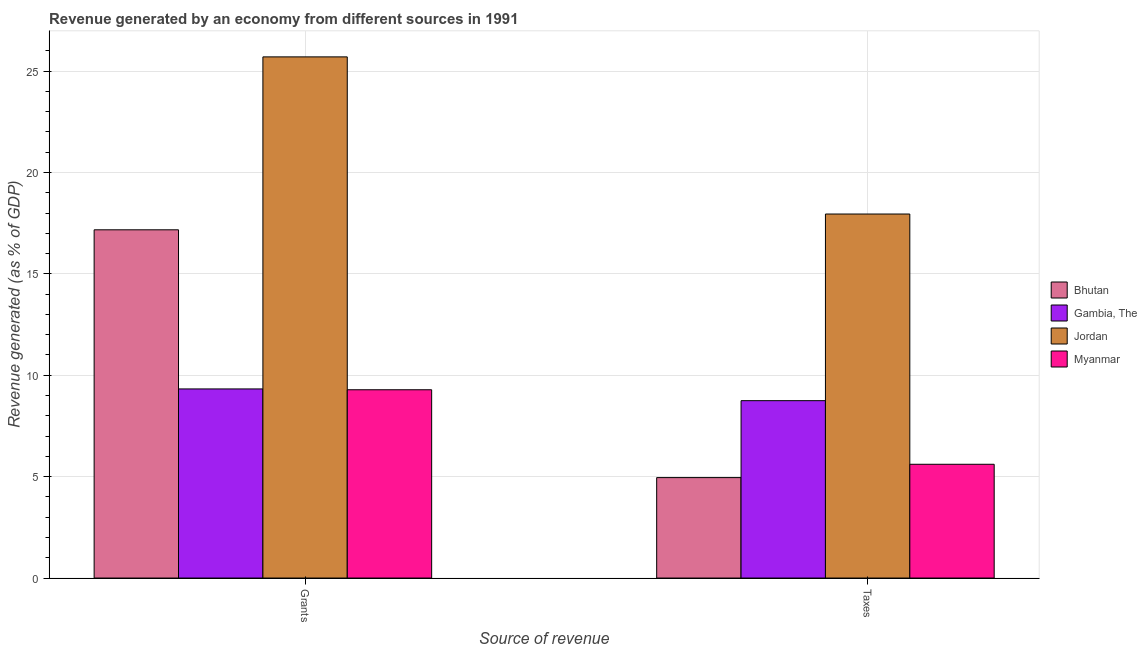How many different coloured bars are there?
Provide a succinct answer. 4. How many groups of bars are there?
Give a very brief answer. 2. How many bars are there on the 1st tick from the left?
Ensure brevity in your answer.  4. What is the label of the 1st group of bars from the left?
Provide a succinct answer. Grants. What is the revenue generated by taxes in Jordan?
Give a very brief answer. 17.95. Across all countries, what is the maximum revenue generated by taxes?
Offer a very short reply. 17.95. Across all countries, what is the minimum revenue generated by taxes?
Provide a short and direct response. 4.95. In which country was the revenue generated by taxes maximum?
Your answer should be compact. Jordan. In which country was the revenue generated by grants minimum?
Give a very brief answer. Myanmar. What is the total revenue generated by taxes in the graph?
Provide a succinct answer. 37.26. What is the difference between the revenue generated by taxes in Bhutan and that in Myanmar?
Your response must be concise. -0.66. What is the difference between the revenue generated by grants in Bhutan and the revenue generated by taxes in Jordan?
Your response must be concise. -0.78. What is the average revenue generated by taxes per country?
Offer a very short reply. 9.31. What is the difference between the revenue generated by grants and revenue generated by taxes in Myanmar?
Make the answer very short. 3.67. What is the ratio of the revenue generated by grants in Jordan to that in Bhutan?
Offer a very short reply. 1.5. Is the revenue generated by taxes in Myanmar less than that in Bhutan?
Your answer should be compact. No. In how many countries, is the revenue generated by grants greater than the average revenue generated by grants taken over all countries?
Keep it short and to the point. 2. What does the 1st bar from the left in Taxes represents?
Offer a very short reply. Bhutan. What does the 4th bar from the right in Grants represents?
Give a very brief answer. Bhutan. How many bars are there?
Provide a short and direct response. 8. Are all the bars in the graph horizontal?
Offer a terse response. No. How many countries are there in the graph?
Keep it short and to the point. 4. Where does the legend appear in the graph?
Ensure brevity in your answer.  Center right. How are the legend labels stacked?
Offer a terse response. Vertical. What is the title of the graph?
Give a very brief answer. Revenue generated by an economy from different sources in 1991. What is the label or title of the X-axis?
Ensure brevity in your answer.  Source of revenue. What is the label or title of the Y-axis?
Ensure brevity in your answer.  Revenue generated (as % of GDP). What is the Revenue generated (as % of GDP) in Bhutan in Grants?
Give a very brief answer. 17.17. What is the Revenue generated (as % of GDP) of Gambia, The in Grants?
Your answer should be compact. 9.32. What is the Revenue generated (as % of GDP) of Jordan in Grants?
Provide a short and direct response. 25.7. What is the Revenue generated (as % of GDP) of Myanmar in Grants?
Your response must be concise. 9.28. What is the Revenue generated (as % of GDP) in Bhutan in Taxes?
Give a very brief answer. 4.95. What is the Revenue generated (as % of GDP) of Gambia, The in Taxes?
Keep it short and to the point. 8.75. What is the Revenue generated (as % of GDP) in Jordan in Taxes?
Give a very brief answer. 17.95. What is the Revenue generated (as % of GDP) in Myanmar in Taxes?
Keep it short and to the point. 5.61. Across all Source of revenue, what is the maximum Revenue generated (as % of GDP) of Bhutan?
Offer a very short reply. 17.17. Across all Source of revenue, what is the maximum Revenue generated (as % of GDP) of Gambia, The?
Give a very brief answer. 9.32. Across all Source of revenue, what is the maximum Revenue generated (as % of GDP) in Jordan?
Your answer should be compact. 25.7. Across all Source of revenue, what is the maximum Revenue generated (as % of GDP) in Myanmar?
Provide a succinct answer. 9.28. Across all Source of revenue, what is the minimum Revenue generated (as % of GDP) of Bhutan?
Ensure brevity in your answer.  4.95. Across all Source of revenue, what is the minimum Revenue generated (as % of GDP) in Gambia, The?
Keep it short and to the point. 8.75. Across all Source of revenue, what is the minimum Revenue generated (as % of GDP) in Jordan?
Offer a terse response. 17.95. Across all Source of revenue, what is the minimum Revenue generated (as % of GDP) of Myanmar?
Your answer should be very brief. 5.61. What is the total Revenue generated (as % of GDP) of Bhutan in the graph?
Offer a terse response. 22.12. What is the total Revenue generated (as % of GDP) in Gambia, The in the graph?
Keep it short and to the point. 18.07. What is the total Revenue generated (as % of GDP) of Jordan in the graph?
Your answer should be very brief. 43.65. What is the total Revenue generated (as % of GDP) in Myanmar in the graph?
Your answer should be compact. 14.89. What is the difference between the Revenue generated (as % of GDP) in Bhutan in Grants and that in Taxes?
Your answer should be compact. 12.22. What is the difference between the Revenue generated (as % of GDP) in Gambia, The in Grants and that in Taxes?
Keep it short and to the point. 0.58. What is the difference between the Revenue generated (as % of GDP) in Jordan in Grants and that in Taxes?
Offer a terse response. 7.75. What is the difference between the Revenue generated (as % of GDP) in Myanmar in Grants and that in Taxes?
Keep it short and to the point. 3.67. What is the difference between the Revenue generated (as % of GDP) of Bhutan in Grants and the Revenue generated (as % of GDP) of Gambia, The in Taxes?
Offer a very short reply. 8.43. What is the difference between the Revenue generated (as % of GDP) in Bhutan in Grants and the Revenue generated (as % of GDP) in Jordan in Taxes?
Keep it short and to the point. -0.78. What is the difference between the Revenue generated (as % of GDP) in Bhutan in Grants and the Revenue generated (as % of GDP) in Myanmar in Taxes?
Provide a succinct answer. 11.56. What is the difference between the Revenue generated (as % of GDP) in Gambia, The in Grants and the Revenue generated (as % of GDP) in Jordan in Taxes?
Give a very brief answer. -8.63. What is the difference between the Revenue generated (as % of GDP) in Gambia, The in Grants and the Revenue generated (as % of GDP) in Myanmar in Taxes?
Ensure brevity in your answer.  3.71. What is the difference between the Revenue generated (as % of GDP) of Jordan in Grants and the Revenue generated (as % of GDP) of Myanmar in Taxes?
Provide a succinct answer. 20.09. What is the average Revenue generated (as % of GDP) in Bhutan per Source of revenue?
Provide a short and direct response. 11.06. What is the average Revenue generated (as % of GDP) of Gambia, The per Source of revenue?
Provide a succinct answer. 9.04. What is the average Revenue generated (as % of GDP) of Jordan per Source of revenue?
Provide a short and direct response. 21.82. What is the average Revenue generated (as % of GDP) of Myanmar per Source of revenue?
Offer a very short reply. 7.45. What is the difference between the Revenue generated (as % of GDP) of Bhutan and Revenue generated (as % of GDP) of Gambia, The in Grants?
Ensure brevity in your answer.  7.85. What is the difference between the Revenue generated (as % of GDP) in Bhutan and Revenue generated (as % of GDP) in Jordan in Grants?
Offer a terse response. -8.53. What is the difference between the Revenue generated (as % of GDP) in Bhutan and Revenue generated (as % of GDP) in Myanmar in Grants?
Make the answer very short. 7.89. What is the difference between the Revenue generated (as % of GDP) of Gambia, The and Revenue generated (as % of GDP) of Jordan in Grants?
Provide a succinct answer. -16.37. What is the difference between the Revenue generated (as % of GDP) in Gambia, The and Revenue generated (as % of GDP) in Myanmar in Grants?
Give a very brief answer. 0.04. What is the difference between the Revenue generated (as % of GDP) of Jordan and Revenue generated (as % of GDP) of Myanmar in Grants?
Make the answer very short. 16.41. What is the difference between the Revenue generated (as % of GDP) in Bhutan and Revenue generated (as % of GDP) in Gambia, The in Taxes?
Provide a succinct answer. -3.79. What is the difference between the Revenue generated (as % of GDP) of Bhutan and Revenue generated (as % of GDP) of Jordan in Taxes?
Make the answer very short. -13. What is the difference between the Revenue generated (as % of GDP) in Bhutan and Revenue generated (as % of GDP) in Myanmar in Taxes?
Ensure brevity in your answer.  -0.66. What is the difference between the Revenue generated (as % of GDP) of Gambia, The and Revenue generated (as % of GDP) of Jordan in Taxes?
Provide a succinct answer. -9.2. What is the difference between the Revenue generated (as % of GDP) of Gambia, The and Revenue generated (as % of GDP) of Myanmar in Taxes?
Your response must be concise. 3.14. What is the difference between the Revenue generated (as % of GDP) of Jordan and Revenue generated (as % of GDP) of Myanmar in Taxes?
Provide a succinct answer. 12.34. What is the ratio of the Revenue generated (as % of GDP) in Bhutan in Grants to that in Taxes?
Your answer should be compact. 3.47. What is the ratio of the Revenue generated (as % of GDP) of Gambia, The in Grants to that in Taxes?
Keep it short and to the point. 1.07. What is the ratio of the Revenue generated (as % of GDP) of Jordan in Grants to that in Taxes?
Your response must be concise. 1.43. What is the ratio of the Revenue generated (as % of GDP) in Myanmar in Grants to that in Taxes?
Make the answer very short. 1.65. What is the difference between the highest and the second highest Revenue generated (as % of GDP) in Bhutan?
Keep it short and to the point. 12.22. What is the difference between the highest and the second highest Revenue generated (as % of GDP) in Gambia, The?
Your response must be concise. 0.58. What is the difference between the highest and the second highest Revenue generated (as % of GDP) of Jordan?
Provide a short and direct response. 7.75. What is the difference between the highest and the second highest Revenue generated (as % of GDP) of Myanmar?
Your response must be concise. 3.67. What is the difference between the highest and the lowest Revenue generated (as % of GDP) in Bhutan?
Your response must be concise. 12.22. What is the difference between the highest and the lowest Revenue generated (as % of GDP) in Gambia, The?
Offer a very short reply. 0.58. What is the difference between the highest and the lowest Revenue generated (as % of GDP) of Jordan?
Give a very brief answer. 7.75. What is the difference between the highest and the lowest Revenue generated (as % of GDP) in Myanmar?
Your response must be concise. 3.67. 